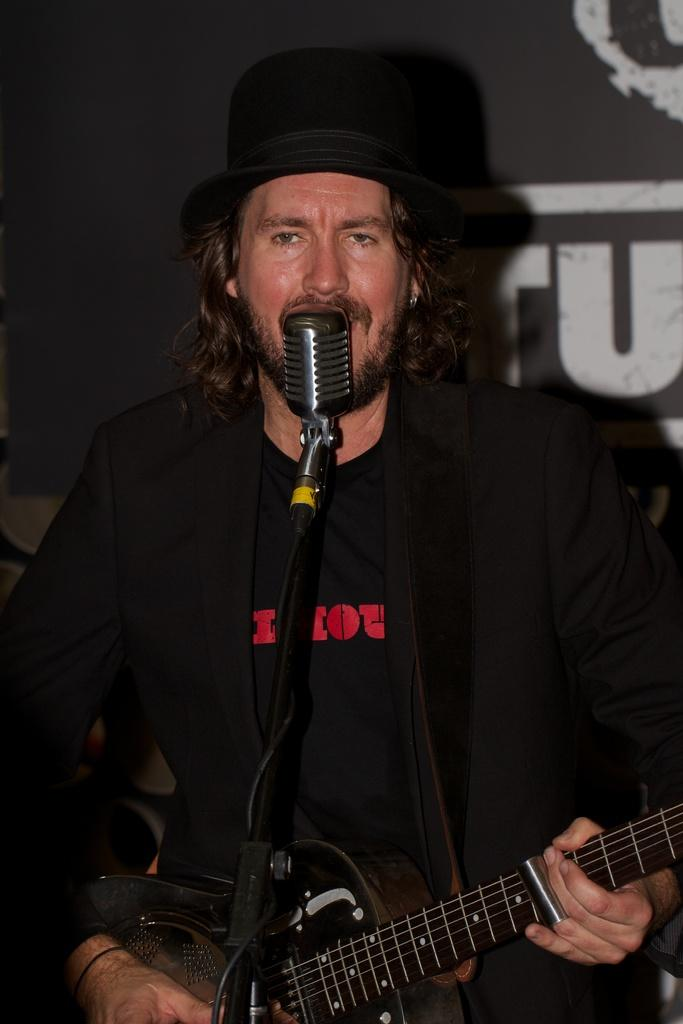Who is present in the image? There is a person in the image. What is the person wearing? The person is wearing a hat. What object is the person holding? The person is holding a guitar. What is in front of the person? There is a microphone in front of the person. How much disgust does the person feel in the image? There is no indication of the person's feelings or emotions in the image, so it cannot be determined how much disgust they might feel. 